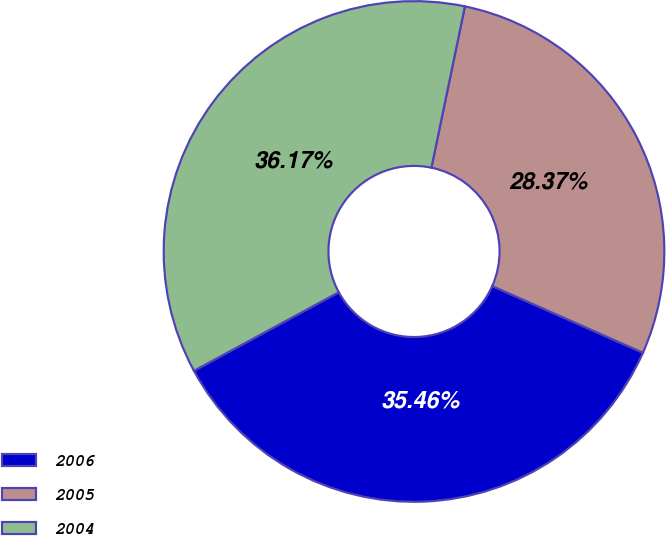Convert chart to OTSL. <chart><loc_0><loc_0><loc_500><loc_500><pie_chart><fcel>2006<fcel>2005<fcel>2004<nl><fcel>35.46%<fcel>28.37%<fcel>36.17%<nl></chart> 